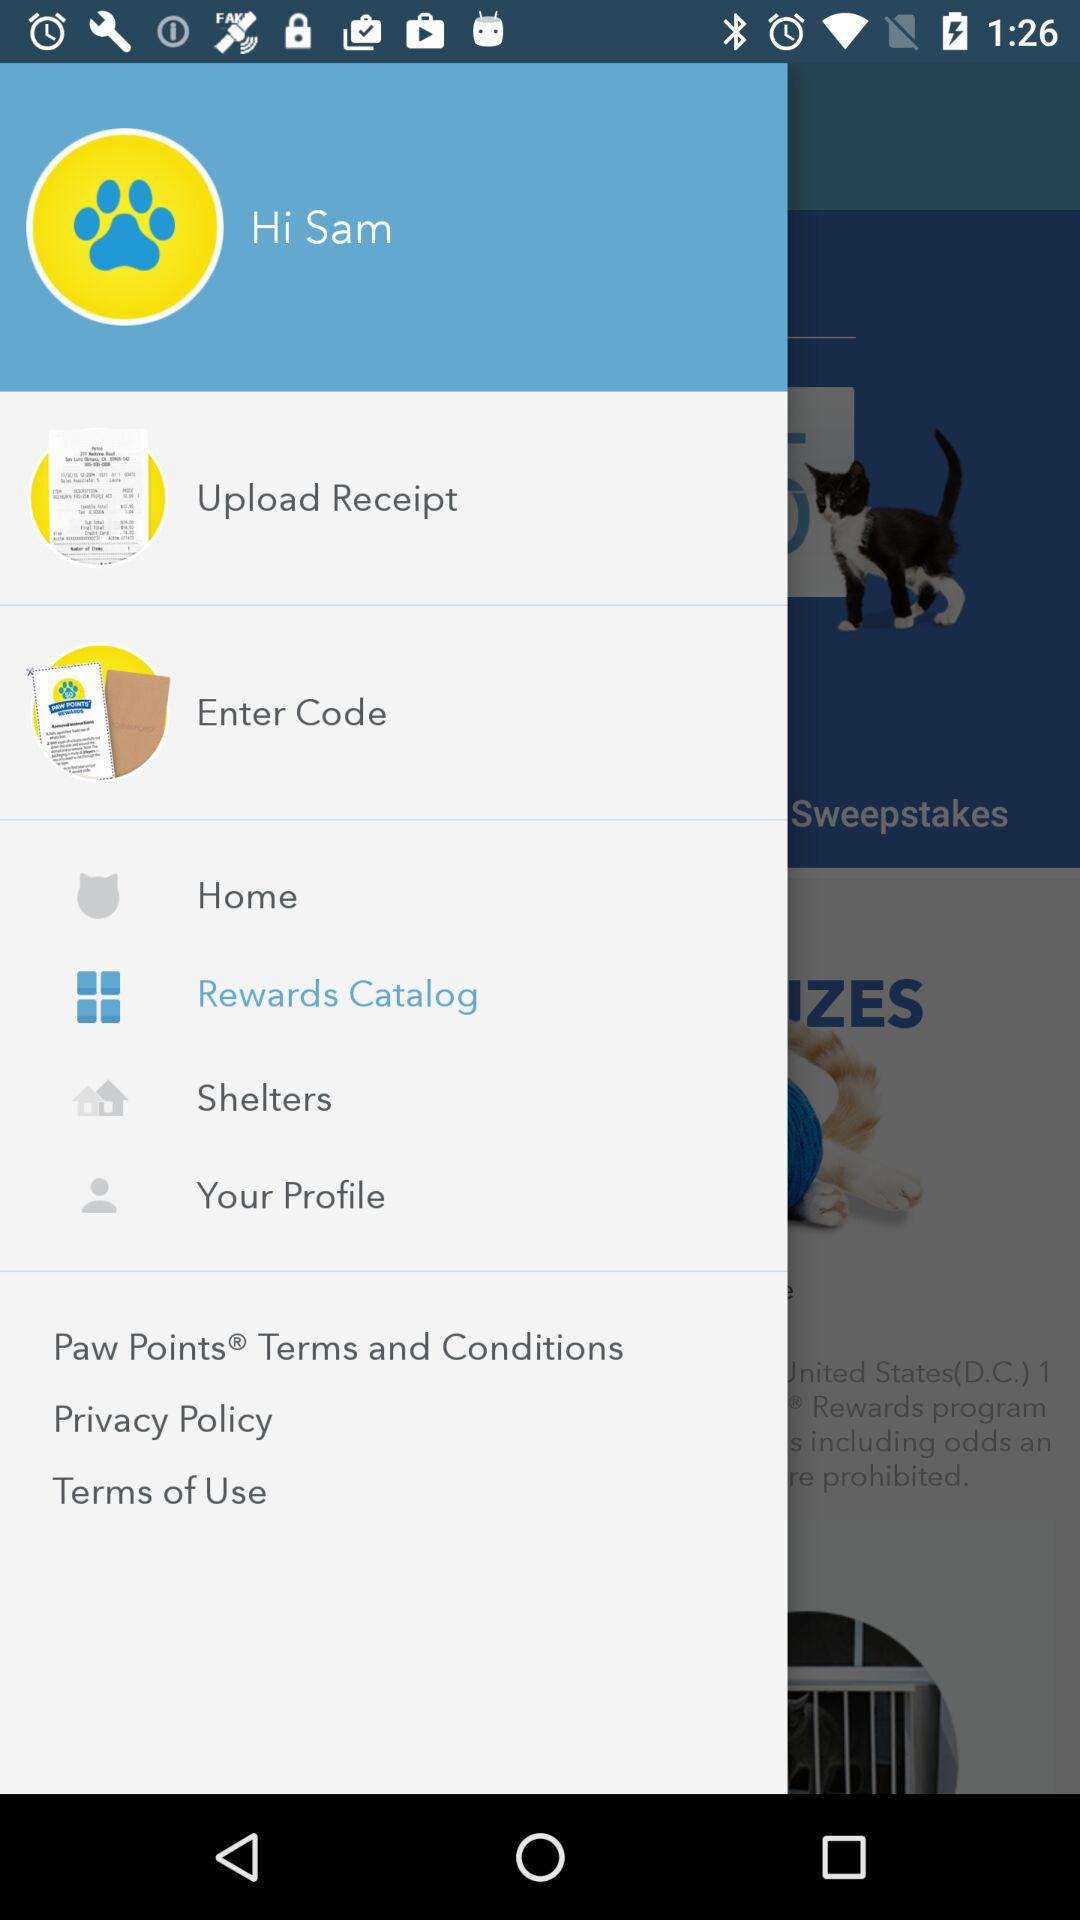What is the user name? The user name is Sam. 